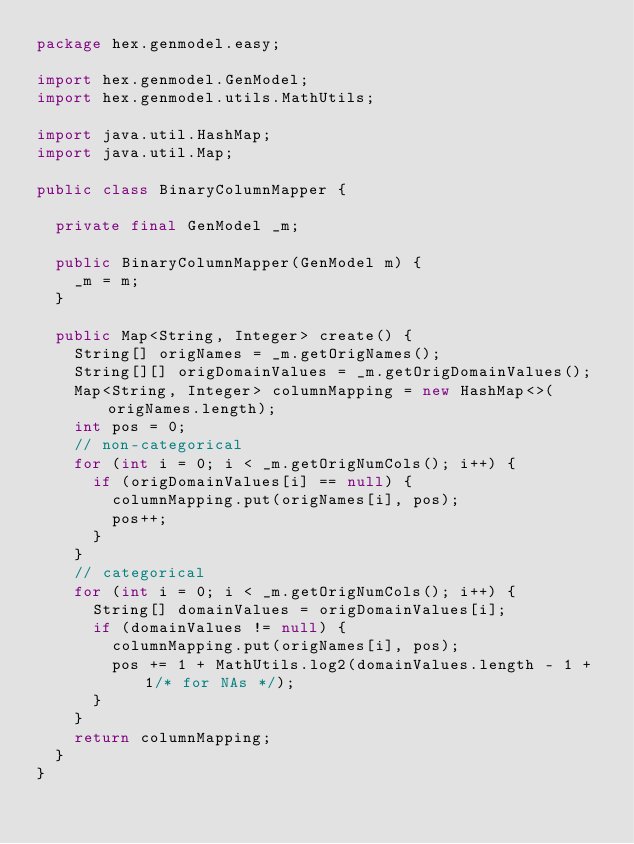Convert code to text. <code><loc_0><loc_0><loc_500><loc_500><_Java_>package hex.genmodel.easy;

import hex.genmodel.GenModel;
import hex.genmodel.utils.MathUtils;

import java.util.HashMap;
import java.util.Map;

public class BinaryColumnMapper {

  private final GenModel _m;

  public BinaryColumnMapper(GenModel m) {
    _m = m;
  }

  public Map<String, Integer> create() {
    String[] origNames = _m.getOrigNames();
    String[][] origDomainValues = _m.getOrigDomainValues();
    Map<String, Integer> columnMapping = new HashMap<>(origNames.length);
    int pos = 0;
    // non-categorical
    for (int i = 0; i < _m.getOrigNumCols(); i++) {
      if (origDomainValues[i] == null) {
        columnMapping.put(origNames[i], pos);
        pos++;
      }
    }
    // categorical
    for (int i = 0; i < _m.getOrigNumCols(); i++) {
      String[] domainValues = origDomainValues[i];
      if (domainValues != null) {
        columnMapping.put(origNames[i], pos);
        pos += 1 + MathUtils.log2(domainValues.length - 1 + 1/* for NAs */);
      }
    }
    return columnMapping;
  }
}
</code> 